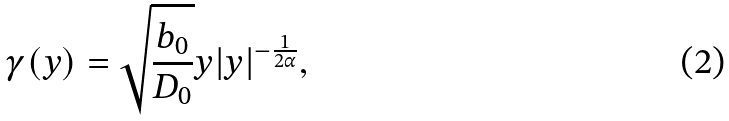<formula> <loc_0><loc_0><loc_500><loc_500>\gamma ( y ) = \sqrt { \frac { b _ { 0 } } { D _ { 0 } } } y | y | ^ { - \frac { 1 } { 2 \alpha } } ,</formula> 